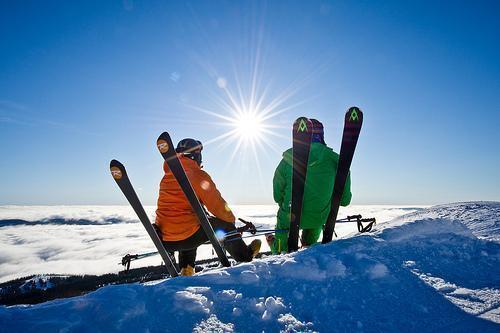How many people are in this picture?
Give a very brief answer. 2. 